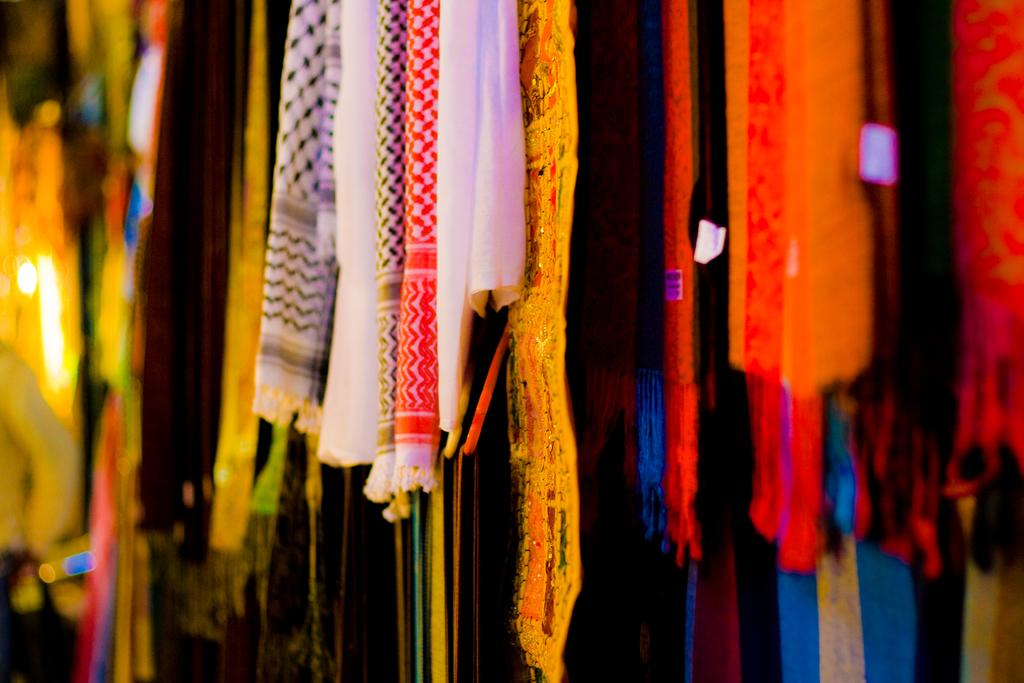What can be observed about the clothes in the image? There are different color clothes in the image. Can you describe any specific details about the image's appearance? The corners of the image are blurred. Are there any bears celebrating a birthday in the image? There is no mention of bears or a birthday in the image; it only features different color clothes and blurred corners. 